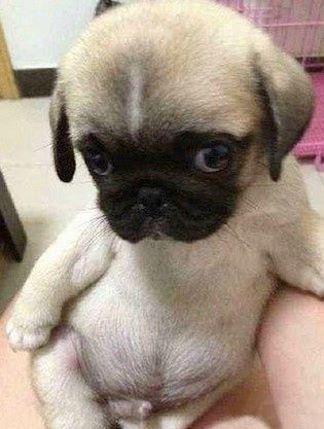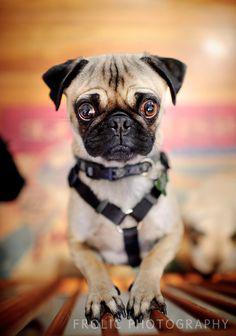The first image is the image on the left, the second image is the image on the right. Given the left and right images, does the statement "Not even one dog has it's mouth open." hold true? Answer yes or no. Yes. The first image is the image on the left, the second image is the image on the right. Examine the images to the left and right. Is the description "Each image contains a single pug which faces forward, and the pug on the right wears something in addition to a collar." accurate? Answer yes or no. Yes. 